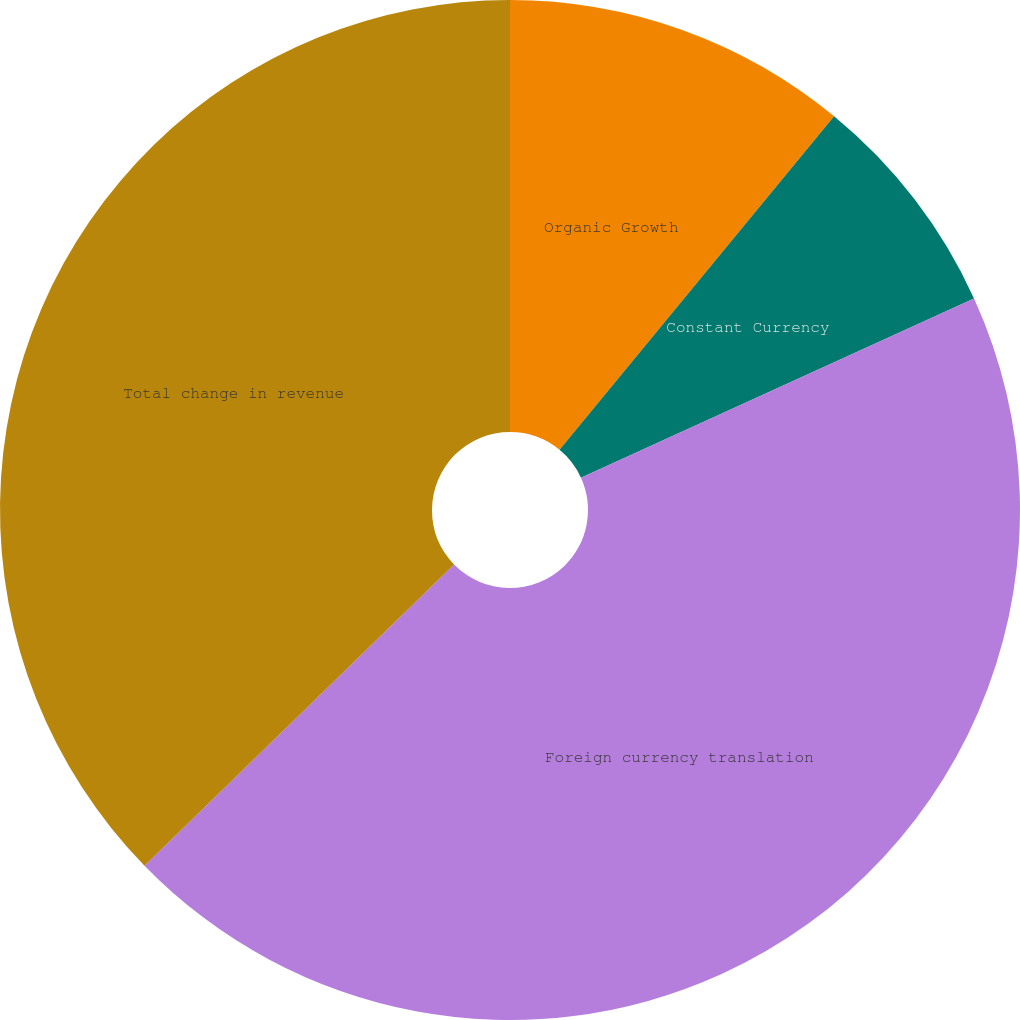Convert chart. <chart><loc_0><loc_0><loc_500><loc_500><pie_chart><fcel>Organic Growth<fcel>Constant Currency<fcel>Foreign currency translation<fcel>Total change in revenue<nl><fcel>10.96%<fcel>7.23%<fcel>44.52%<fcel>37.28%<nl></chart> 